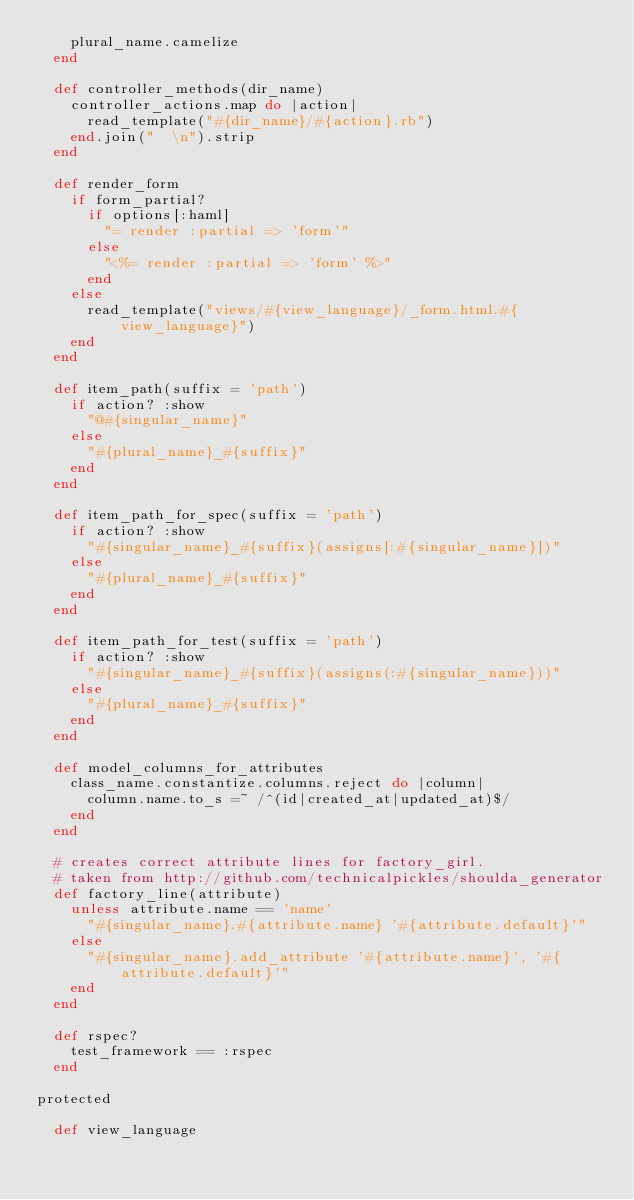<code> <loc_0><loc_0><loc_500><loc_500><_Ruby_>    plural_name.camelize
  end
  
  def controller_methods(dir_name)
    controller_actions.map do |action|
      read_template("#{dir_name}/#{action}.rb")
    end.join("  \n").strip
  end
  
  def render_form
    if form_partial?
      if options[:haml]
        "= render :partial => 'form'"
      else
        "<%= render :partial => 'form' %>"
      end
    else
      read_template("views/#{view_language}/_form.html.#{view_language}")
    end
  end
  
  def item_path(suffix = 'path')
    if action? :show
      "@#{singular_name}"
    else
      "#{plural_name}_#{suffix}"
    end
  end
  
  def item_path_for_spec(suffix = 'path')
    if action? :show
      "#{singular_name}_#{suffix}(assigns[:#{singular_name}])"
    else
      "#{plural_name}_#{suffix}"
    end
  end
  
  def item_path_for_test(suffix = 'path')
    if action? :show
      "#{singular_name}_#{suffix}(assigns(:#{singular_name}))"
    else
      "#{plural_name}_#{suffix}"
    end
  end
  
  def model_columns_for_attributes
    class_name.constantize.columns.reject do |column|
      column.name.to_s =~ /^(id|created_at|updated_at)$/
    end
  end
  
  # creates correct attribute lines for factory_girl. 
  # taken from http://github.com/technicalpickles/shoulda_generator
  def factory_line(attribute)
    unless attribute.name == 'name'
      "#{singular_name}.#{attribute.name} '#{attribute.default}'"
    else
      "#{singular_name}.add_attribute '#{attribute.name}', '#{attribute.default}'"
    end
  end
  
  def rspec?
    test_framework == :rspec
  end
  
protected
  
  def view_language</code> 